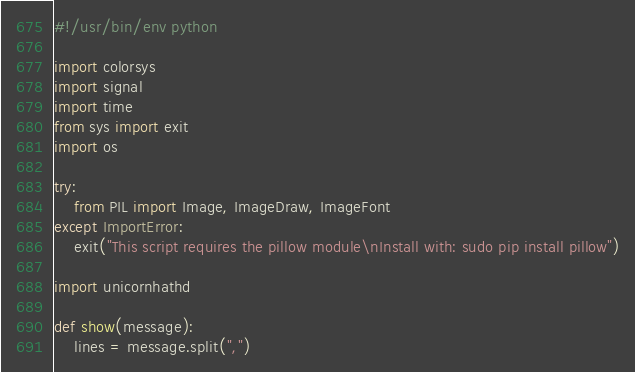Convert code to text. <code><loc_0><loc_0><loc_500><loc_500><_Python_>#!/usr/bin/env python

import colorsys
import signal
import time
from sys import exit
import os

try:
    from PIL import Image, ImageDraw, ImageFont
except ImportError:
    exit("This script requires the pillow module\nInstall with: sudo pip install pillow")

import unicornhathd

def show(message):
    lines = message.split(",")
</code> 